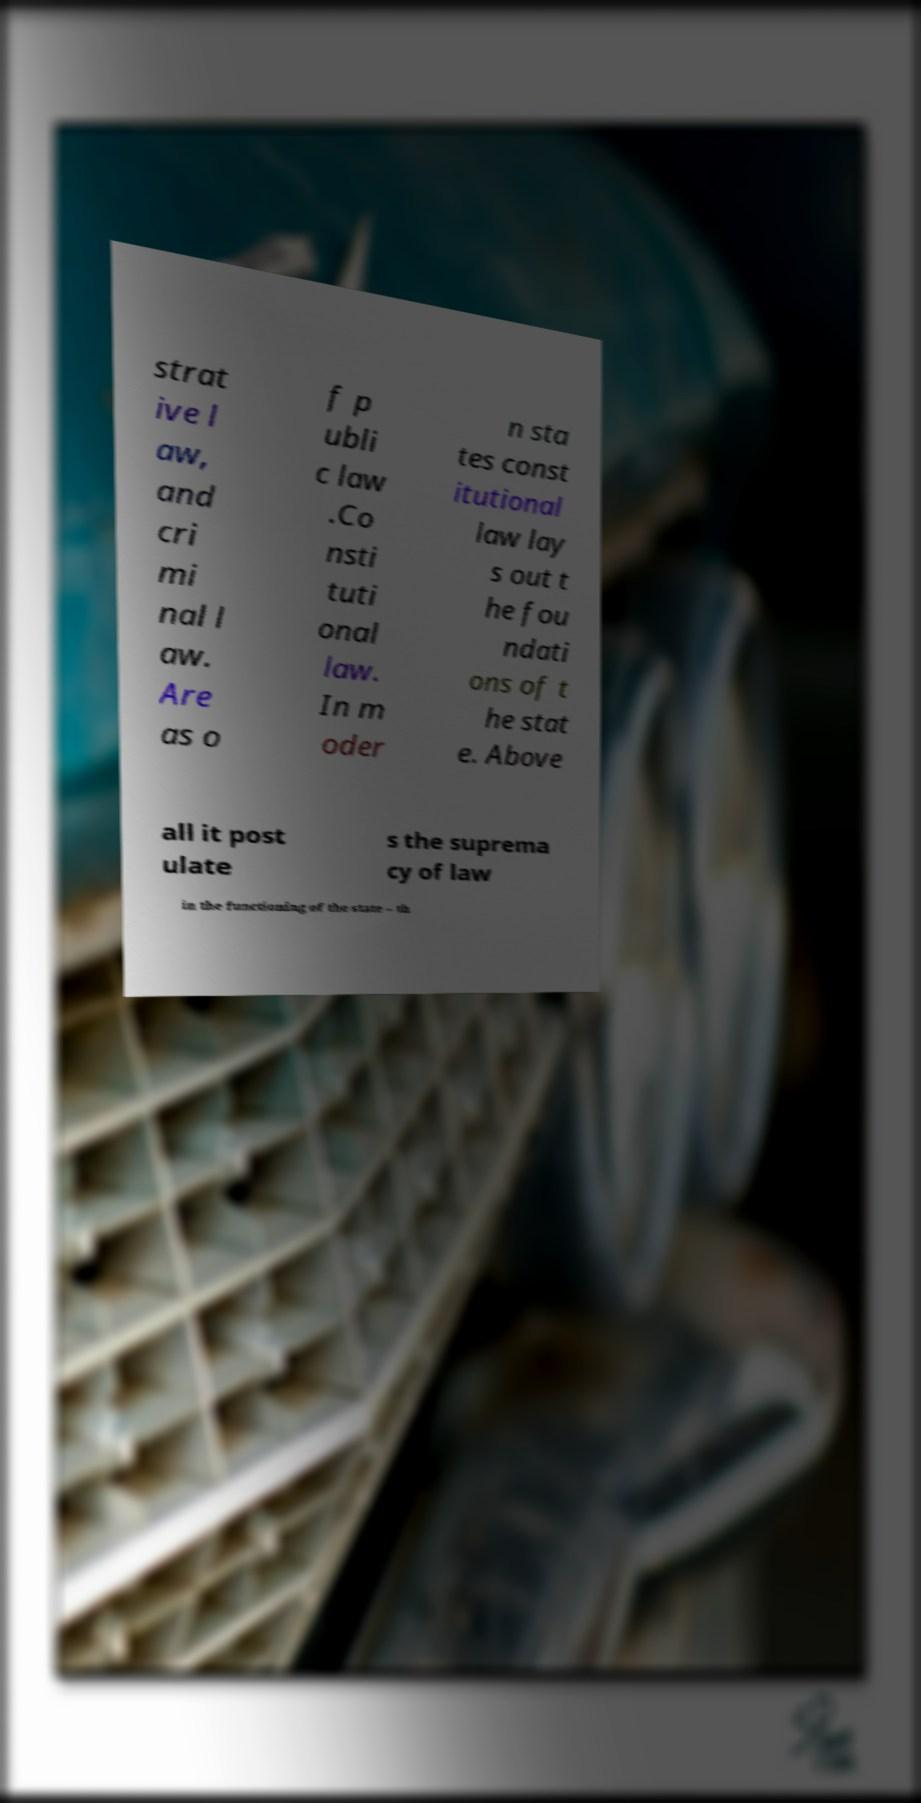I need the written content from this picture converted into text. Can you do that? strat ive l aw, and cri mi nal l aw. Are as o f p ubli c law .Co nsti tuti onal law. In m oder n sta tes const itutional law lay s out t he fou ndati ons of t he stat e. Above all it post ulate s the suprema cy of law in the functioning of the state – th 